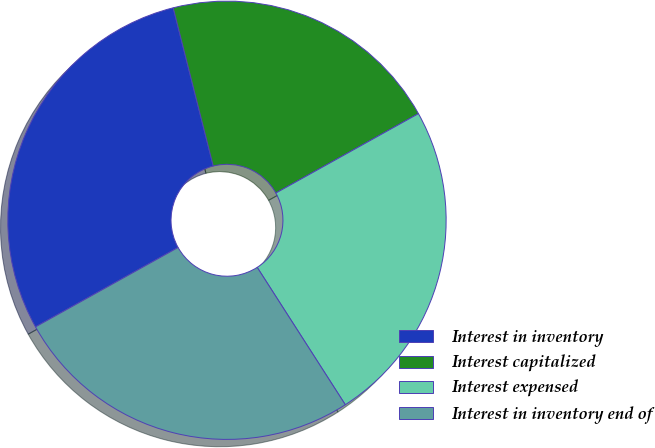Convert chart to OTSL. <chart><loc_0><loc_0><loc_500><loc_500><pie_chart><fcel>Interest in inventory<fcel>Interest capitalized<fcel>Interest expensed<fcel>Interest in inventory end of<nl><fcel>29.14%<fcel>20.86%<fcel>24.01%<fcel>25.99%<nl></chart> 